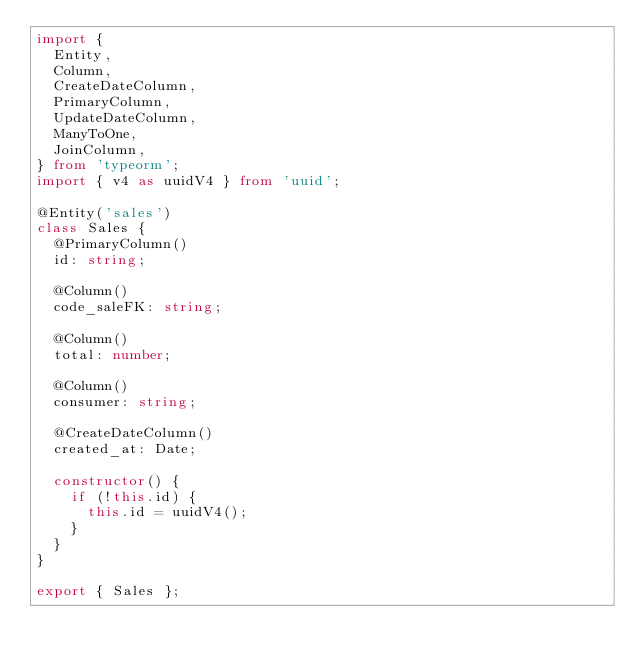Convert code to text. <code><loc_0><loc_0><loc_500><loc_500><_TypeScript_>import {
  Entity,
  Column,
  CreateDateColumn,
  PrimaryColumn,
  UpdateDateColumn,
  ManyToOne,
  JoinColumn,
} from 'typeorm';
import { v4 as uuidV4 } from 'uuid';

@Entity('sales')
class Sales {
  @PrimaryColumn()
  id: string;

  @Column()
  code_saleFK: string;

  @Column()
  total: number;

  @Column()
  consumer: string;

  @CreateDateColumn()
  created_at: Date;

  constructor() {
    if (!this.id) {
      this.id = uuidV4();
    }
  }
}

export { Sales };
</code> 